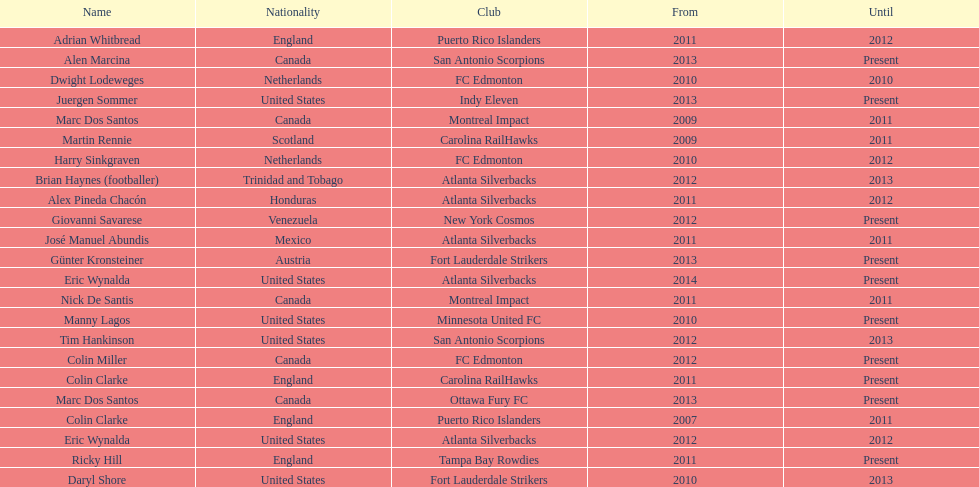How long did colin clarke coach the puerto rico islanders? 4 years. 